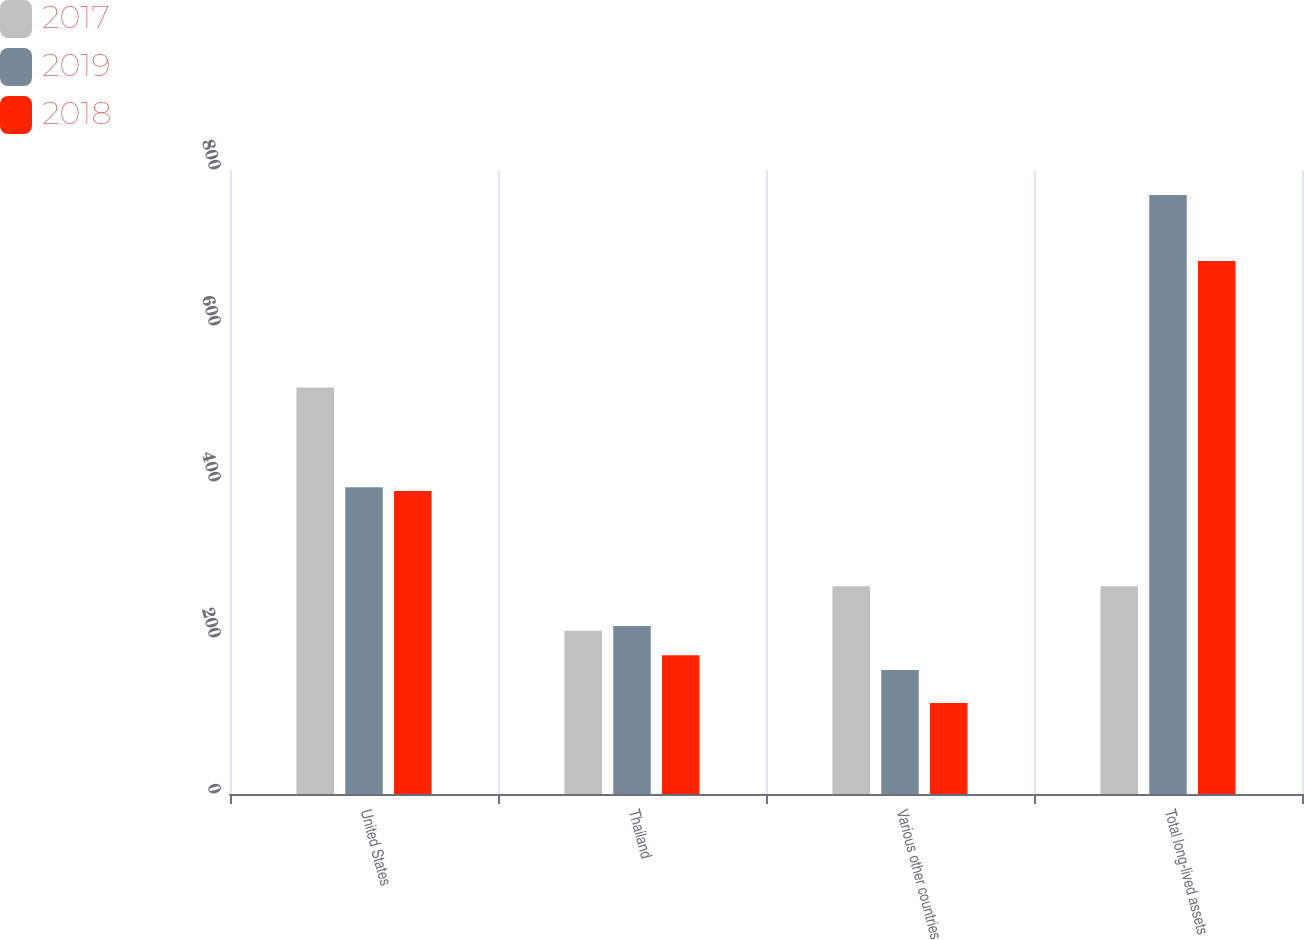Convert chart. <chart><loc_0><loc_0><loc_500><loc_500><stacked_bar_chart><ecel><fcel>United States<fcel>Thailand<fcel>Various other countries<fcel>Total long-lived assets<nl><fcel>2017<fcel>521.1<fcel>209.3<fcel>266.3<fcel>266.3<nl><fcel>2019<fcel>393.3<fcel>215.5<fcel>159.1<fcel>767.9<nl><fcel>2018<fcel>388.5<fcel>178<fcel>116.8<fcel>683.3<nl></chart> 